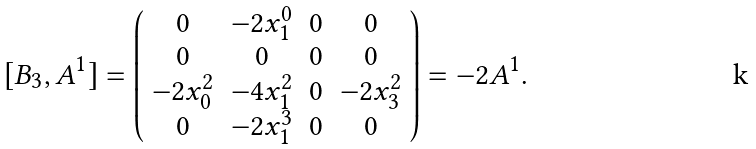<formula> <loc_0><loc_0><loc_500><loc_500>[ B _ { 3 } , A ^ { 1 } ] = \left ( \begin{array} { c c c c } 0 & - 2 x ^ { 0 } _ { 1 } & 0 & 0 \\ 0 & 0 & 0 & 0 \\ - 2 x ^ { 2 } _ { 0 } & - 4 x ^ { 2 } _ { 1 } & 0 & - 2 x ^ { 2 } _ { 3 } \\ 0 & - 2 x ^ { 3 } _ { 1 } & 0 & 0 \\ \end{array} \right ) = - 2 A ^ { 1 } .</formula> 